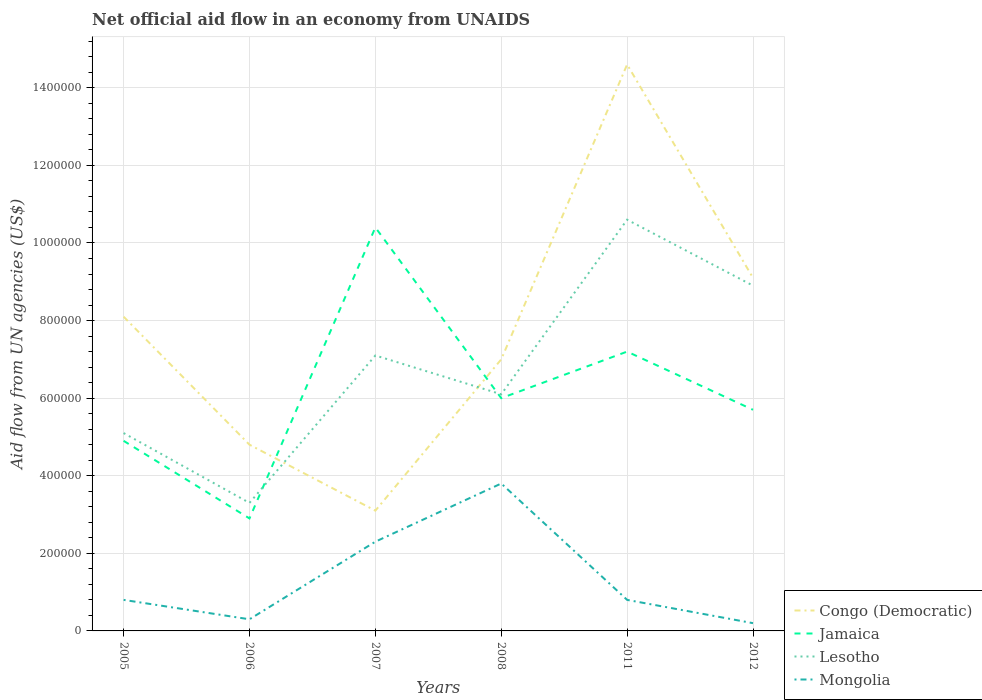In which year was the net official aid flow in Congo (Democratic) maximum?
Give a very brief answer. 2007. What is the total net official aid flow in Mongolia in the graph?
Ensure brevity in your answer.  -3.00e+05. What is the difference between the highest and the second highest net official aid flow in Jamaica?
Make the answer very short. 7.50e+05. What is the difference between the highest and the lowest net official aid flow in Congo (Democratic)?
Offer a very short reply. 3. How many lines are there?
Make the answer very short. 4. Does the graph contain any zero values?
Offer a very short reply. No. How many legend labels are there?
Provide a short and direct response. 4. What is the title of the graph?
Give a very brief answer. Net official aid flow in an economy from UNAIDS. Does "Myanmar" appear as one of the legend labels in the graph?
Provide a short and direct response. No. What is the label or title of the X-axis?
Your response must be concise. Years. What is the label or title of the Y-axis?
Keep it short and to the point. Aid flow from UN agencies (US$). What is the Aid flow from UN agencies (US$) in Congo (Democratic) in 2005?
Ensure brevity in your answer.  8.10e+05. What is the Aid flow from UN agencies (US$) of Lesotho in 2005?
Your answer should be very brief. 5.10e+05. What is the Aid flow from UN agencies (US$) of Lesotho in 2006?
Keep it short and to the point. 3.30e+05. What is the Aid flow from UN agencies (US$) in Mongolia in 2006?
Give a very brief answer. 3.00e+04. What is the Aid flow from UN agencies (US$) of Congo (Democratic) in 2007?
Offer a terse response. 3.10e+05. What is the Aid flow from UN agencies (US$) in Jamaica in 2007?
Keep it short and to the point. 1.04e+06. What is the Aid flow from UN agencies (US$) of Lesotho in 2007?
Your answer should be very brief. 7.10e+05. What is the Aid flow from UN agencies (US$) in Congo (Democratic) in 2008?
Offer a terse response. 7.00e+05. What is the Aid flow from UN agencies (US$) in Jamaica in 2008?
Keep it short and to the point. 6.00e+05. What is the Aid flow from UN agencies (US$) of Lesotho in 2008?
Ensure brevity in your answer.  6.10e+05. What is the Aid flow from UN agencies (US$) in Congo (Democratic) in 2011?
Your answer should be very brief. 1.46e+06. What is the Aid flow from UN agencies (US$) of Jamaica in 2011?
Provide a short and direct response. 7.20e+05. What is the Aid flow from UN agencies (US$) of Lesotho in 2011?
Your response must be concise. 1.06e+06. What is the Aid flow from UN agencies (US$) in Mongolia in 2011?
Your answer should be compact. 8.00e+04. What is the Aid flow from UN agencies (US$) of Congo (Democratic) in 2012?
Your answer should be very brief. 9.10e+05. What is the Aid flow from UN agencies (US$) in Jamaica in 2012?
Keep it short and to the point. 5.70e+05. What is the Aid flow from UN agencies (US$) in Lesotho in 2012?
Provide a short and direct response. 8.90e+05. What is the Aid flow from UN agencies (US$) of Mongolia in 2012?
Your answer should be very brief. 2.00e+04. Across all years, what is the maximum Aid flow from UN agencies (US$) of Congo (Democratic)?
Offer a very short reply. 1.46e+06. Across all years, what is the maximum Aid flow from UN agencies (US$) in Jamaica?
Your response must be concise. 1.04e+06. Across all years, what is the maximum Aid flow from UN agencies (US$) in Lesotho?
Offer a terse response. 1.06e+06. Across all years, what is the minimum Aid flow from UN agencies (US$) of Lesotho?
Keep it short and to the point. 3.30e+05. What is the total Aid flow from UN agencies (US$) in Congo (Democratic) in the graph?
Your response must be concise. 4.67e+06. What is the total Aid flow from UN agencies (US$) of Jamaica in the graph?
Keep it short and to the point. 3.71e+06. What is the total Aid flow from UN agencies (US$) of Lesotho in the graph?
Offer a terse response. 4.11e+06. What is the total Aid flow from UN agencies (US$) of Mongolia in the graph?
Keep it short and to the point. 8.20e+05. What is the difference between the Aid flow from UN agencies (US$) in Congo (Democratic) in 2005 and that in 2006?
Ensure brevity in your answer.  3.30e+05. What is the difference between the Aid flow from UN agencies (US$) in Jamaica in 2005 and that in 2006?
Your answer should be compact. 2.00e+05. What is the difference between the Aid flow from UN agencies (US$) in Lesotho in 2005 and that in 2006?
Offer a terse response. 1.80e+05. What is the difference between the Aid flow from UN agencies (US$) of Congo (Democratic) in 2005 and that in 2007?
Make the answer very short. 5.00e+05. What is the difference between the Aid flow from UN agencies (US$) of Jamaica in 2005 and that in 2007?
Make the answer very short. -5.50e+05. What is the difference between the Aid flow from UN agencies (US$) of Mongolia in 2005 and that in 2007?
Ensure brevity in your answer.  -1.50e+05. What is the difference between the Aid flow from UN agencies (US$) in Congo (Democratic) in 2005 and that in 2008?
Give a very brief answer. 1.10e+05. What is the difference between the Aid flow from UN agencies (US$) of Congo (Democratic) in 2005 and that in 2011?
Give a very brief answer. -6.50e+05. What is the difference between the Aid flow from UN agencies (US$) in Jamaica in 2005 and that in 2011?
Your response must be concise. -2.30e+05. What is the difference between the Aid flow from UN agencies (US$) in Lesotho in 2005 and that in 2011?
Ensure brevity in your answer.  -5.50e+05. What is the difference between the Aid flow from UN agencies (US$) in Jamaica in 2005 and that in 2012?
Make the answer very short. -8.00e+04. What is the difference between the Aid flow from UN agencies (US$) in Lesotho in 2005 and that in 2012?
Your response must be concise. -3.80e+05. What is the difference between the Aid flow from UN agencies (US$) of Congo (Democratic) in 2006 and that in 2007?
Provide a succinct answer. 1.70e+05. What is the difference between the Aid flow from UN agencies (US$) of Jamaica in 2006 and that in 2007?
Ensure brevity in your answer.  -7.50e+05. What is the difference between the Aid flow from UN agencies (US$) of Lesotho in 2006 and that in 2007?
Your response must be concise. -3.80e+05. What is the difference between the Aid flow from UN agencies (US$) of Jamaica in 2006 and that in 2008?
Your response must be concise. -3.10e+05. What is the difference between the Aid flow from UN agencies (US$) in Lesotho in 2006 and that in 2008?
Your answer should be very brief. -2.80e+05. What is the difference between the Aid flow from UN agencies (US$) of Mongolia in 2006 and that in 2008?
Give a very brief answer. -3.50e+05. What is the difference between the Aid flow from UN agencies (US$) of Congo (Democratic) in 2006 and that in 2011?
Your answer should be very brief. -9.80e+05. What is the difference between the Aid flow from UN agencies (US$) of Jamaica in 2006 and that in 2011?
Your response must be concise. -4.30e+05. What is the difference between the Aid flow from UN agencies (US$) of Lesotho in 2006 and that in 2011?
Provide a short and direct response. -7.30e+05. What is the difference between the Aid flow from UN agencies (US$) in Congo (Democratic) in 2006 and that in 2012?
Your response must be concise. -4.30e+05. What is the difference between the Aid flow from UN agencies (US$) in Jamaica in 2006 and that in 2012?
Your answer should be compact. -2.80e+05. What is the difference between the Aid flow from UN agencies (US$) in Lesotho in 2006 and that in 2012?
Provide a short and direct response. -5.60e+05. What is the difference between the Aid flow from UN agencies (US$) of Mongolia in 2006 and that in 2012?
Your answer should be very brief. 10000. What is the difference between the Aid flow from UN agencies (US$) in Congo (Democratic) in 2007 and that in 2008?
Your answer should be very brief. -3.90e+05. What is the difference between the Aid flow from UN agencies (US$) in Lesotho in 2007 and that in 2008?
Provide a short and direct response. 1.00e+05. What is the difference between the Aid flow from UN agencies (US$) of Mongolia in 2007 and that in 2008?
Offer a very short reply. -1.50e+05. What is the difference between the Aid flow from UN agencies (US$) in Congo (Democratic) in 2007 and that in 2011?
Offer a terse response. -1.15e+06. What is the difference between the Aid flow from UN agencies (US$) of Lesotho in 2007 and that in 2011?
Offer a very short reply. -3.50e+05. What is the difference between the Aid flow from UN agencies (US$) of Congo (Democratic) in 2007 and that in 2012?
Give a very brief answer. -6.00e+05. What is the difference between the Aid flow from UN agencies (US$) of Jamaica in 2007 and that in 2012?
Keep it short and to the point. 4.70e+05. What is the difference between the Aid flow from UN agencies (US$) of Congo (Democratic) in 2008 and that in 2011?
Your answer should be compact. -7.60e+05. What is the difference between the Aid flow from UN agencies (US$) of Lesotho in 2008 and that in 2011?
Your response must be concise. -4.50e+05. What is the difference between the Aid flow from UN agencies (US$) of Jamaica in 2008 and that in 2012?
Offer a very short reply. 3.00e+04. What is the difference between the Aid flow from UN agencies (US$) of Lesotho in 2008 and that in 2012?
Your response must be concise. -2.80e+05. What is the difference between the Aid flow from UN agencies (US$) in Mongolia in 2008 and that in 2012?
Provide a short and direct response. 3.60e+05. What is the difference between the Aid flow from UN agencies (US$) in Congo (Democratic) in 2011 and that in 2012?
Ensure brevity in your answer.  5.50e+05. What is the difference between the Aid flow from UN agencies (US$) of Lesotho in 2011 and that in 2012?
Give a very brief answer. 1.70e+05. What is the difference between the Aid flow from UN agencies (US$) of Mongolia in 2011 and that in 2012?
Provide a short and direct response. 6.00e+04. What is the difference between the Aid flow from UN agencies (US$) of Congo (Democratic) in 2005 and the Aid flow from UN agencies (US$) of Jamaica in 2006?
Make the answer very short. 5.20e+05. What is the difference between the Aid flow from UN agencies (US$) of Congo (Democratic) in 2005 and the Aid flow from UN agencies (US$) of Mongolia in 2006?
Your response must be concise. 7.80e+05. What is the difference between the Aid flow from UN agencies (US$) of Congo (Democratic) in 2005 and the Aid flow from UN agencies (US$) of Mongolia in 2007?
Your answer should be compact. 5.80e+05. What is the difference between the Aid flow from UN agencies (US$) in Congo (Democratic) in 2005 and the Aid flow from UN agencies (US$) in Lesotho in 2008?
Your answer should be compact. 2.00e+05. What is the difference between the Aid flow from UN agencies (US$) of Congo (Democratic) in 2005 and the Aid flow from UN agencies (US$) of Mongolia in 2008?
Provide a short and direct response. 4.30e+05. What is the difference between the Aid flow from UN agencies (US$) in Lesotho in 2005 and the Aid flow from UN agencies (US$) in Mongolia in 2008?
Give a very brief answer. 1.30e+05. What is the difference between the Aid flow from UN agencies (US$) in Congo (Democratic) in 2005 and the Aid flow from UN agencies (US$) in Lesotho in 2011?
Provide a succinct answer. -2.50e+05. What is the difference between the Aid flow from UN agencies (US$) of Congo (Democratic) in 2005 and the Aid flow from UN agencies (US$) of Mongolia in 2011?
Your answer should be very brief. 7.30e+05. What is the difference between the Aid flow from UN agencies (US$) in Jamaica in 2005 and the Aid flow from UN agencies (US$) in Lesotho in 2011?
Your response must be concise. -5.70e+05. What is the difference between the Aid flow from UN agencies (US$) in Jamaica in 2005 and the Aid flow from UN agencies (US$) in Mongolia in 2011?
Provide a succinct answer. 4.10e+05. What is the difference between the Aid flow from UN agencies (US$) of Congo (Democratic) in 2005 and the Aid flow from UN agencies (US$) of Mongolia in 2012?
Provide a succinct answer. 7.90e+05. What is the difference between the Aid flow from UN agencies (US$) in Jamaica in 2005 and the Aid flow from UN agencies (US$) in Lesotho in 2012?
Provide a short and direct response. -4.00e+05. What is the difference between the Aid flow from UN agencies (US$) in Jamaica in 2005 and the Aid flow from UN agencies (US$) in Mongolia in 2012?
Your response must be concise. 4.70e+05. What is the difference between the Aid flow from UN agencies (US$) in Congo (Democratic) in 2006 and the Aid flow from UN agencies (US$) in Jamaica in 2007?
Offer a terse response. -5.60e+05. What is the difference between the Aid flow from UN agencies (US$) in Congo (Democratic) in 2006 and the Aid flow from UN agencies (US$) in Mongolia in 2007?
Your answer should be very brief. 2.50e+05. What is the difference between the Aid flow from UN agencies (US$) in Jamaica in 2006 and the Aid flow from UN agencies (US$) in Lesotho in 2007?
Your answer should be very brief. -4.20e+05. What is the difference between the Aid flow from UN agencies (US$) in Congo (Democratic) in 2006 and the Aid flow from UN agencies (US$) in Lesotho in 2008?
Your response must be concise. -1.30e+05. What is the difference between the Aid flow from UN agencies (US$) in Jamaica in 2006 and the Aid flow from UN agencies (US$) in Lesotho in 2008?
Provide a succinct answer. -3.20e+05. What is the difference between the Aid flow from UN agencies (US$) of Lesotho in 2006 and the Aid flow from UN agencies (US$) of Mongolia in 2008?
Make the answer very short. -5.00e+04. What is the difference between the Aid flow from UN agencies (US$) in Congo (Democratic) in 2006 and the Aid flow from UN agencies (US$) in Lesotho in 2011?
Ensure brevity in your answer.  -5.80e+05. What is the difference between the Aid flow from UN agencies (US$) in Jamaica in 2006 and the Aid flow from UN agencies (US$) in Lesotho in 2011?
Provide a succinct answer. -7.70e+05. What is the difference between the Aid flow from UN agencies (US$) of Lesotho in 2006 and the Aid flow from UN agencies (US$) of Mongolia in 2011?
Offer a very short reply. 2.50e+05. What is the difference between the Aid flow from UN agencies (US$) in Congo (Democratic) in 2006 and the Aid flow from UN agencies (US$) in Jamaica in 2012?
Keep it short and to the point. -9.00e+04. What is the difference between the Aid flow from UN agencies (US$) in Congo (Democratic) in 2006 and the Aid flow from UN agencies (US$) in Lesotho in 2012?
Your response must be concise. -4.10e+05. What is the difference between the Aid flow from UN agencies (US$) of Jamaica in 2006 and the Aid flow from UN agencies (US$) of Lesotho in 2012?
Keep it short and to the point. -6.00e+05. What is the difference between the Aid flow from UN agencies (US$) in Jamaica in 2006 and the Aid flow from UN agencies (US$) in Mongolia in 2012?
Your response must be concise. 2.70e+05. What is the difference between the Aid flow from UN agencies (US$) of Congo (Democratic) in 2007 and the Aid flow from UN agencies (US$) of Jamaica in 2008?
Provide a succinct answer. -2.90e+05. What is the difference between the Aid flow from UN agencies (US$) of Jamaica in 2007 and the Aid flow from UN agencies (US$) of Lesotho in 2008?
Keep it short and to the point. 4.30e+05. What is the difference between the Aid flow from UN agencies (US$) in Lesotho in 2007 and the Aid flow from UN agencies (US$) in Mongolia in 2008?
Provide a succinct answer. 3.30e+05. What is the difference between the Aid flow from UN agencies (US$) of Congo (Democratic) in 2007 and the Aid flow from UN agencies (US$) of Jamaica in 2011?
Provide a short and direct response. -4.10e+05. What is the difference between the Aid flow from UN agencies (US$) in Congo (Democratic) in 2007 and the Aid flow from UN agencies (US$) in Lesotho in 2011?
Provide a succinct answer. -7.50e+05. What is the difference between the Aid flow from UN agencies (US$) of Congo (Democratic) in 2007 and the Aid flow from UN agencies (US$) of Mongolia in 2011?
Offer a terse response. 2.30e+05. What is the difference between the Aid flow from UN agencies (US$) in Jamaica in 2007 and the Aid flow from UN agencies (US$) in Mongolia in 2011?
Offer a terse response. 9.60e+05. What is the difference between the Aid flow from UN agencies (US$) in Lesotho in 2007 and the Aid flow from UN agencies (US$) in Mongolia in 2011?
Keep it short and to the point. 6.30e+05. What is the difference between the Aid flow from UN agencies (US$) in Congo (Democratic) in 2007 and the Aid flow from UN agencies (US$) in Jamaica in 2012?
Make the answer very short. -2.60e+05. What is the difference between the Aid flow from UN agencies (US$) of Congo (Democratic) in 2007 and the Aid flow from UN agencies (US$) of Lesotho in 2012?
Provide a short and direct response. -5.80e+05. What is the difference between the Aid flow from UN agencies (US$) of Jamaica in 2007 and the Aid flow from UN agencies (US$) of Lesotho in 2012?
Ensure brevity in your answer.  1.50e+05. What is the difference between the Aid flow from UN agencies (US$) in Jamaica in 2007 and the Aid flow from UN agencies (US$) in Mongolia in 2012?
Your answer should be compact. 1.02e+06. What is the difference between the Aid flow from UN agencies (US$) in Lesotho in 2007 and the Aid flow from UN agencies (US$) in Mongolia in 2012?
Your answer should be very brief. 6.90e+05. What is the difference between the Aid flow from UN agencies (US$) of Congo (Democratic) in 2008 and the Aid flow from UN agencies (US$) of Lesotho in 2011?
Provide a short and direct response. -3.60e+05. What is the difference between the Aid flow from UN agencies (US$) in Congo (Democratic) in 2008 and the Aid flow from UN agencies (US$) in Mongolia in 2011?
Give a very brief answer. 6.20e+05. What is the difference between the Aid flow from UN agencies (US$) in Jamaica in 2008 and the Aid flow from UN agencies (US$) in Lesotho in 2011?
Offer a terse response. -4.60e+05. What is the difference between the Aid flow from UN agencies (US$) in Jamaica in 2008 and the Aid flow from UN agencies (US$) in Mongolia in 2011?
Your response must be concise. 5.20e+05. What is the difference between the Aid flow from UN agencies (US$) of Lesotho in 2008 and the Aid flow from UN agencies (US$) of Mongolia in 2011?
Offer a terse response. 5.30e+05. What is the difference between the Aid flow from UN agencies (US$) in Congo (Democratic) in 2008 and the Aid flow from UN agencies (US$) in Lesotho in 2012?
Your answer should be compact. -1.90e+05. What is the difference between the Aid flow from UN agencies (US$) in Congo (Democratic) in 2008 and the Aid flow from UN agencies (US$) in Mongolia in 2012?
Keep it short and to the point. 6.80e+05. What is the difference between the Aid flow from UN agencies (US$) in Jamaica in 2008 and the Aid flow from UN agencies (US$) in Mongolia in 2012?
Keep it short and to the point. 5.80e+05. What is the difference between the Aid flow from UN agencies (US$) of Lesotho in 2008 and the Aid flow from UN agencies (US$) of Mongolia in 2012?
Keep it short and to the point. 5.90e+05. What is the difference between the Aid flow from UN agencies (US$) in Congo (Democratic) in 2011 and the Aid flow from UN agencies (US$) in Jamaica in 2012?
Offer a terse response. 8.90e+05. What is the difference between the Aid flow from UN agencies (US$) of Congo (Democratic) in 2011 and the Aid flow from UN agencies (US$) of Lesotho in 2012?
Offer a terse response. 5.70e+05. What is the difference between the Aid flow from UN agencies (US$) of Congo (Democratic) in 2011 and the Aid flow from UN agencies (US$) of Mongolia in 2012?
Offer a very short reply. 1.44e+06. What is the difference between the Aid flow from UN agencies (US$) of Jamaica in 2011 and the Aid flow from UN agencies (US$) of Mongolia in 2012?
Your answer should be very brief. 7.00e+05. What is the difference between the Aid flow from UN agencies (US$) in Lesotho in 2011 and the Aid flow from UN agencies (US$) in Mongolia in 2012?
Make the answer very short. 1.04e+06. What is the average Aid flow from UN agencies (US$) in Congo (Democratic) per year?
Provide a short and direct response. 7.78e+05. What is the average Aid flow from UN agencies (US$) in Jamaica per year?
Make the answer very short. 6.18e+05. What is the average Aid flow from UN agencies (US$) in Lesotho per year?
Ensure brevity in your answer.  6.85e+05. What is the average Aid flow from UN agencies (US$) in Mongolia per year?
Offer a terse response. 1.37e+05. In the year 2005, what is the difference between the Aid flow from UN agencies (US$) of Congo (Democratic) and Aid flow from UN agencies (US$) of Mongolia?
Ensure brevity in your answer.  7.30e+05. In the year 2005, what is the difference between the Aid flow from UN agencies (US$) of Jamaica and Aid flow from UN agencies (US$) of Mongolia?
Provide a short and direct response. 4.10e+05. In the year 2006, what is the difference between the Aid flow from UN agencies (US$) in Congo (Democratic) and Aid flow from UN agencies (US$) in Lesotho?
Make the answer very short. 1.50e+05. In the year 2006, what is the difference between the Aid flow from UN agencies (US$) of Jamaica and Aid flow from UN agencies (US$) of Lesotho?
Keep it short and to the point. -4.00e+04. In the year 2006, what is the difference between the Aid flow from UN agencies (US$) of Lesotho and Aid flow from UN agencies (US$) of Mongolia?
Keep it short and to the point. 3.00e+05. In the year 2007, what is the difference between the Aid flow from UN agencies (US$) of Congo (Democratic) and Aid flow from UN agencies (US$) of Jamaica?
Provide a succinct answer. -7.30e+05. In the year 2007, what is the difference between the Aid flow from UN agencies (US$) of Congo (Democratic) and Aid flow from UN agencies (US$) of Lesotho?
Your answer should be very brief. -4.00e+05. In the year 2007, what is the difference between the Aid flow from UN agencies (US$) of Jamaica and Aid flow from UN agencies (US$) of Mongolia?
Offer a terse response. 8.10e+05. In the year 2007, what is the difference between the Aid flow from UN agencies (US$) of Lesotho and Aid flow from UN agencies (US$) of Mongolia?
Provide a succinct answer. 4.80e+05. In the year 2008, what is the difference between the Aid flow from UN agencies (US$) in Congo (Democratic) and Aid flow from UN agencies (US$) in Jamaica?
Keep it short and to the point. 1.00e+05. In the year 2008, what is the difference between the Aid flow from UN agencies (US$) of Congo (Democratic) and Aid flow from UN agencies (US$) of Mongolia?
Your response must be concise. 3.20e+05. In the year 2008, what is the difference between the Aid flow from UN agencies (US$) in Jamaica and Aid flow from UN agencies (US$) in Lesotho?
Keep it short and to the point. -10000. In the year 2011, what is the difference between the Aid flow from UN agencies (US$) in Congo (Democratic) and Aid flow from UN agencies (US$) in Jamaica?
Keep it short and to the point. 7.40e+05. In the year 2011, what is the difference between the Aid flow from UN agencies (US$) in Congo (Democratic) and Aid flow from UN agencies (US$) in Mongolia?
Ensure brevity in your answer.  1.38e+06. In the year 2011, what is the difference between the Aid flow from UN agencies (US$) in Jamaica and Aid flow from UN agencies (US$) in Mongolia?
Your answer should be very brief. 6.40e+05. In the year 2011, what is the difference between the Aid flow from UN agencies (US$) in Lesotho and Aid flow from UN agencies (US$) in Mongolia?
Provide a succinct answer. 9.80e+05. In the year 2012, what is the difference between the Aid flow from UN agencies (US$) in Congo (Democratic) and Aid flow from UN agencies (US$) in Mongolia?
Give a very brief answer. 8.90e+05. In the year 2012, what is the difference between the Aid flow from UN agencies (US$) of Jamaica and Aid flow from UN agencies (US$) of Lesotho?
Provide a succinct answer. -3.20e+05. In the year 2012, what is the difference between the Aid flow from UN agencies (US$) of Jamaica and Aid flow from UN agencies (US$) of Mongolia?
Offer a terse response. 5.50e+05. In the year 2012, what is the difference between the Aid flow from UN agencies (US$) in Lesotho and Aid flow from UN agencies (US$) in Mongolia?
Offer a very short reply. 8.70e+05. What is the ratio of the Aid flow from UN agencies (US$) of Congo (Democratic) in 2005 to that in 2006?
Make the answer very short. 1.69. What is the ratio of the Aid flow from UN agencies (US$) in Jamaica in 2005 to that in 2006?
Offer a very short reply. 1.69. What is the ratio of the Aid flow from UN agencies (US$) in Lesotho in 2005 to that in 2006?
Your answer should be compact. 1.55. What is the ratio of the Aid flow from UN agencies (US$) in Mongolia in 2005 to that in 2006?
Your response must be concise. 2.67. What is the ratio of the Aid flow from UN agencies (US$) of Congo (Democratic) in 2005 to that in 2007?
Your answer should be very brief. 2.61. What is the ratio of the Aid flow from UN agencies (US$) in Jamaica in 2005 to that in 2007?
Offer a very short reply. 0.47. What is the ratio of the Aid flow from UN agencies (US$) of Lesotho in 2005 to that in 2007?
Make the answer very short. 0.72. What is the ratio of the Aid flow from UN agencies (US$) in Mongolia in 2005 to that in 2007?
Your answer should be very brief. 0.35. What is the ratio of the Aid flow from UN agencies (US$) in Congo (Democratic) in 2005 to that in 2008?
Keep it short and to the point. 1.16. What is the ratio of the Aid flow from UN agencies (US$) of Jamaica in 2005 to that in 2008?
Your answer should be very brief. 0.82. What is the ratio of the Aid flow from UN agencies (US$) in Lesotho in 2005 to that in 2008?
Provide a succinct answer. 0.84. What is the ratio of the Aid flow from UN agencies (US$) of Mongolia in 2005 to that in 2008?
Your answer should be very brief. 0.21. What is the ratio of the Aid flow from UN agencies (US$) of Congo (Democratic) in 2005 to that in 2011?
Ensure brevity in your answer.  0.55. What is the ratio of the Aid flow from UN agencies (US$) in Jamaica in 2005 to that in 2011?
Provide a succinct answer. 0.68. What is the ratio of the Aid flow from UN agencies (US$) in Lesotho in 2005 to that in 2011?
Your response must be concise. 0.48. What is the ratio of the Aid flow from UN agencies (US$) of Mongolia in 2005 to that in 2011?
Ensure brevity in your answer.  1. What is the ratio of the Aid flow from UN agencies (US$) in Congo (Democratic) in 2005 to that in 2012?
Your response must be concise. 0.89. What is the ratio of the Aid flow from UN agencies (US$) in Jamaica in 2005 to that in 2012?
Offer a terse response. 0.86. What is the ratio of the Aid flow from UN agencies (US$) of Lesotho in 2005 to that in 2012?
Provide a short and direct response. 0.57. What is the ratio of the Aid flow from UN agencies (US$) of Congo (Democratic) in 2006 to that in 2007?
Provide a succinct answer. 1.55. What is the ratio of the Aid flow from UN agencies (US$) in Jamaica in 2006 to that in 2007?
Offer a very short reply. 0.28. What is the ratio of the Aid flow from UN agencies (US$) of Lesotho in 2006 to that in 2007?
Give a very brief answer. 0.46. What is the ratio of the Aid flow from UN agencies (US$) of Mongolia in 2006 to that in 2007?
Provide a short and direct response. 0.13. What is the ratio of the Aid flow from UN agencies (US$) of Congo (Democratic) in 2006 to that in 2008?
Offer a terse response. 0.69. What is the ratio of the Aid flow from UN agencies (US$) in Jamaica in 2006 to that in 2008?
Offer a terse response. 0.48. What is the ratio of the Aid flow from UN agencies (US$) of Lesotho in 2006 to that in 2008?
Your answer should be compact. 0.54. What is the ratio of the Aid flow from UN agencies (US$) of Mongolia in 2006 to that in 2008?
Your response must be concise. 0.08. What is the ratio of the Aid flow from UN agencies (US$) of Congo (Democratic) in 2006 to that in 2011?
Make the answer very short. 0.33. What is the ratio of the Aid flow from UN agencies (US$) in Jamaica in 2006 to that in 2011?
Provide a succinct answer. 0.4. What is the ratio of the Aid flow from UN agencies (US$) in Lesotho in 2006 to that in 2011?
Your answer should be very brief. 0.31. What is the ratio of the Aid flow from UN agencies (US$) in Mongolia in 2006 to that in 2011?
Offer a very short reply. 0.38. What is the ratio of the Aid flow from UN agencies (US$) of Congo (Democratic) in 2006 to that in 2012?
Give a very brief answer. 0.53. What is the ratio of the Aid flow from UN agencies (US$) of Jamaica in 2006 to that in 2012?
Your response must be concise. 0.51. What is the ratio of the Aid flow from UN agencies (US$) of Lesotho in 2006 to that in 2012?
Your answer should be very brief. 0.37. What is the ratio of the Aid flow from UN agencies (US$) of Congo (Democratic) in 2007 to that in 2008?
Your answer should be compact. 0.44. What is the ratio of the Aid flow from UN agencies (US$) in Jamaica in 2007 to that in 2008?
Offer a very short reply. 1.73. What is the ratio of the Aid flow from UN agencies (US$) in Lesotho in 2007 to that in 2008?
Give a very brief answer. 1.16. What is the ratio of the Aid flow from UN agencies (US$) in Mongolia in 2007 to that in 2008?
Your answer should be very brief. 0.61. What is the ratio of the Aid flow from UN agencies (US$) of Congo (Democratic) in 2007 to that in 2011?
Your response must be concise. 0.21. What is the ratio of the Aid flow from UN agencies (US$) of Jamaica in 2007 to that in 2011?
Your answer should be compact. 1.44. What is the ratio of the Aid flow from UN agencies (US$) in Lesotho in 2007 to that in 2011?
Offer a terse response. 0.67. What is the ratio of the Aid flow from UN agencies (US$) in Mongolia in 2007 to that in 2011?
Ensure brevity in your answer.  2.88. What is the ratio of the Aid flow from UN agencies (US$) in Congo (Democratic) in 2007 to that in 2012?
Give a very brief answer. 0.34. What is the ratio of the Aid flow from UN agencies (US$) in Jamaica in 2007 to that in 2012?
Your response must be concise. 1.82. What is the ratio of the Aid flow from UN agencies (US$) of Lesotho in 2007 to that in 2012?
Give a very brief answer. 0.8. What is the ratio of the Aid flow from UN agencies (US$) of Congo (Democratic) in 2008 to that in 2011?
Offer a terse response. 0.48. What is the ratio of the Aid flow from UN agencies (US$) of Jamaica in 2008 to that in 2011?
Ensure brevity in your answer.  0.83. What is the ratio of the Aid flow from UN agencies (US$) of Lesotho in 2008 to that in 2011?
Offer a very short reply. 0.58. What is the ratio of the Aid flow from UN agencies (US$) of Mongolia in 2008 to that in 2011?
Provide a short and direct response. 4.75. What is the ratio of the Aid flow from UN agencies (US$) in Congo (Democratic) in 2008 to that in 2012?
Provide a short and direct response. 0.77. What is the ratio of the Aid flow from UN agencies (US$) in Jamaica in 2008 to that in 2012?
Provide a succinct answer. 1.05. What is the ratio of the Aid flow from UN agencies (US$) in Lesotho in 2008 to that in 2012?
Give a very brief answer. 0.69. What is the ratio of the Aid flow from UN agencies (US$) in Congo (Democratic) in 2011 to that in 2012?
Offer a terse response. 1.6. What is the ratio of the Aid flow from UN agencies (US$) in Jamaica in 2011 to that in 2012?
Keep it short and to the point. 1.26. What is the ratio of the Aid flow from UN agencies (US$) in Lesotho in 2011 to that in 2012?
Provide a succinct answer. 1.19. What is the difference between the highest and the second highest Aid flow from UN agencies (US$) of Mongolia?
Your response must be concise. 1.50e+05. What is the difference between the highest and the lowest Aid flow from UN agencies (US$) in Congo (Democratic)?
Give a very brief answer. 1.15e+06. What is the difference between the highest and the lowest Aid flow from UN agencies (US$) of Jamaica?
Provide a short and direct response. 7.50e+05. What is the difference between the highest and the lowest Aid flow from UN agencies (US$) of Lesotho?
Your answer should be very brief. 7.30e+05. What is the difference between the highest and the lowest Aid flow from UN agencies (US$) of Mongolia?
Give a very brief answer. 3.60e+05. 